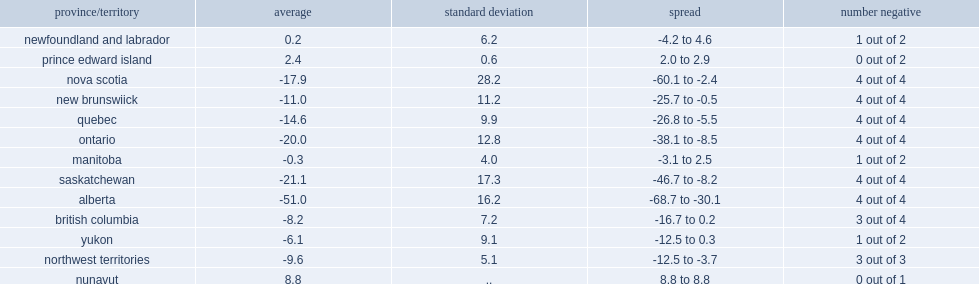Which province has the largest declines? Alberta. Which province has the second largest declines? Saskatchewan. Can you parse all the data within this table? {'header': ['province/territory', 'average', 'standard deviation', 'spread', 'number negative'], 'rows': [['newfoundland and labrador', '0.2', '6.2', '-4.2 to 4.6', '1 out of 2'], ['prince edward island', '2.4', '0.6', '2.0 to 2.9', '0 out of 2'], ['nova scotia', '-17.9', '28.2', '-60.1 to -2.4', '4 out of 4'], ['new brunswiick', '-11.0', '11.2', '-25.7 to -0.5', '4 out of 4'], ['quebec', '-14.6', '9.9', '-26.8 to -5.5', '4 out of 4'], ['ontario', '-20.0', '12.8', '-38.1 to -8.5', '4 out of 4'], ['manitoba', '-0.3', '4.0', '-3.1 to 2.5', '1 out of 2'], ['saskatchewan', '-21.1', '17.3', '-46.7 to -8.2', '4 out of 4'], ['alberta', '-51.0', '16.2', '-68.7 to -30.1', '4 out of 4'], ['british columbia', '-8.2', '7.2', '-16.7 to 0.2', '3 out of 4'], ['yukon', '-6.1', '9.1', '-12.5 to 0.3', '1 out of 2'], ['northwest territories', '-9.6', '5.1', '-12.5 to -3.7', '3 out of 3'], ['nunavut', '8.8', '..', '8.8 to 8.8', '0 out of 1']]} 